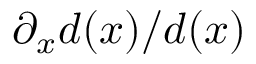Convert formula to latex. <formula><loc_0><loc_0><loc_500><loc_500>\partial _ { x } d ( x ) / d ( x )</formula> 